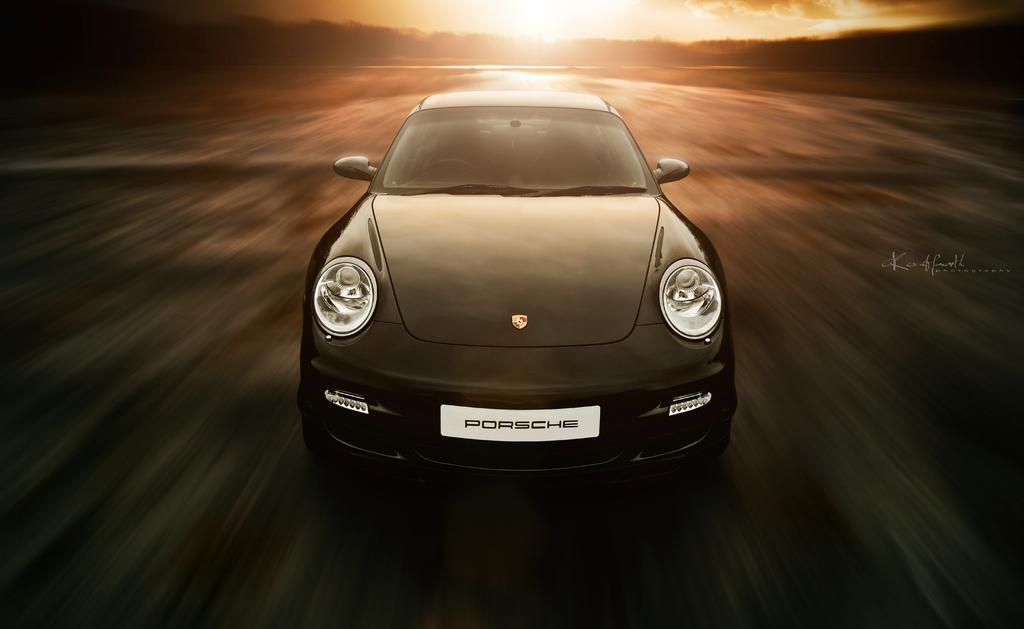What is the main subject of the image? There is a vehicle on the road in the image. What can be seen in the background of the image? There are many trees and the sun visible in the background of the image. What else is visible in the sky? The sky is visible in the background of the image. Where is the swing located in the image? There is no swing present in the image. What type of waste is being disposed of in the image? There is no waste disposal activity depicted in the image. 